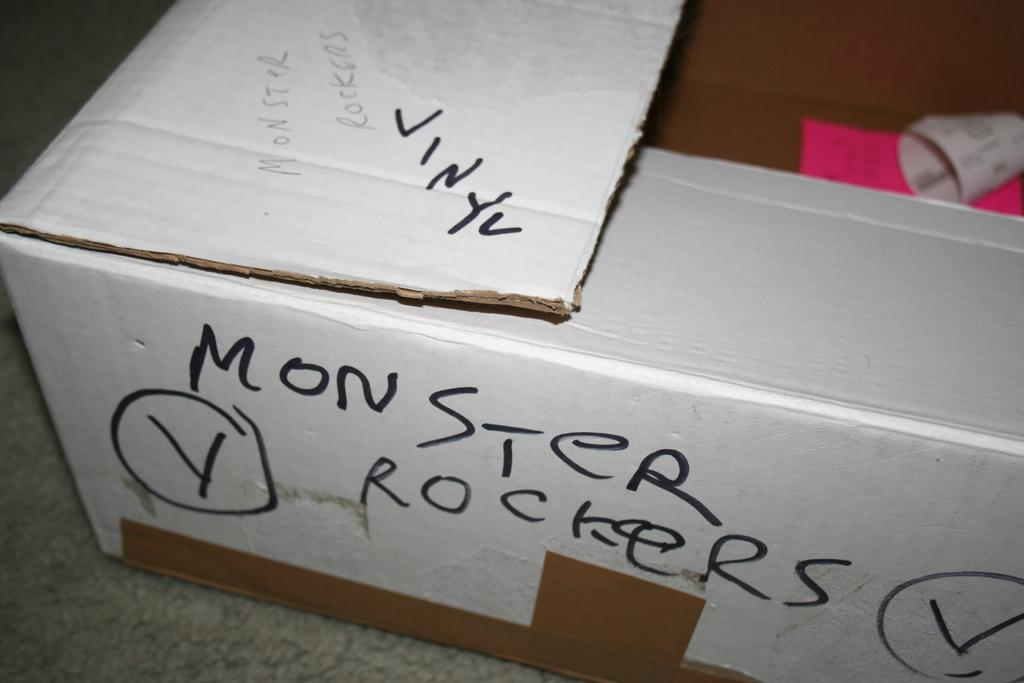<image>
Write a terse but informative summary of the picture. A cardboard box eith recipts inside and Monster Rockers written on the side. 